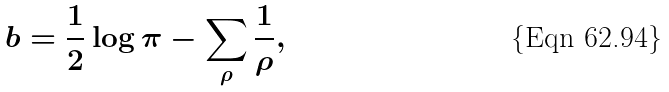<formula> <loc_0><loc_0><loc_500><loc_500>b = \frac { 1 } { 2 } \log \pi - \sum _ { \rho } \frac { 1 } { \rho } ,</formula> 